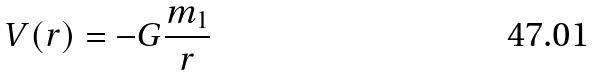Convert formula to latex. <formula><loc_0><loc_0><loc_500><loc_500>V ( r ) = - G \frac { m _ { 1 } } { r }</formula> 